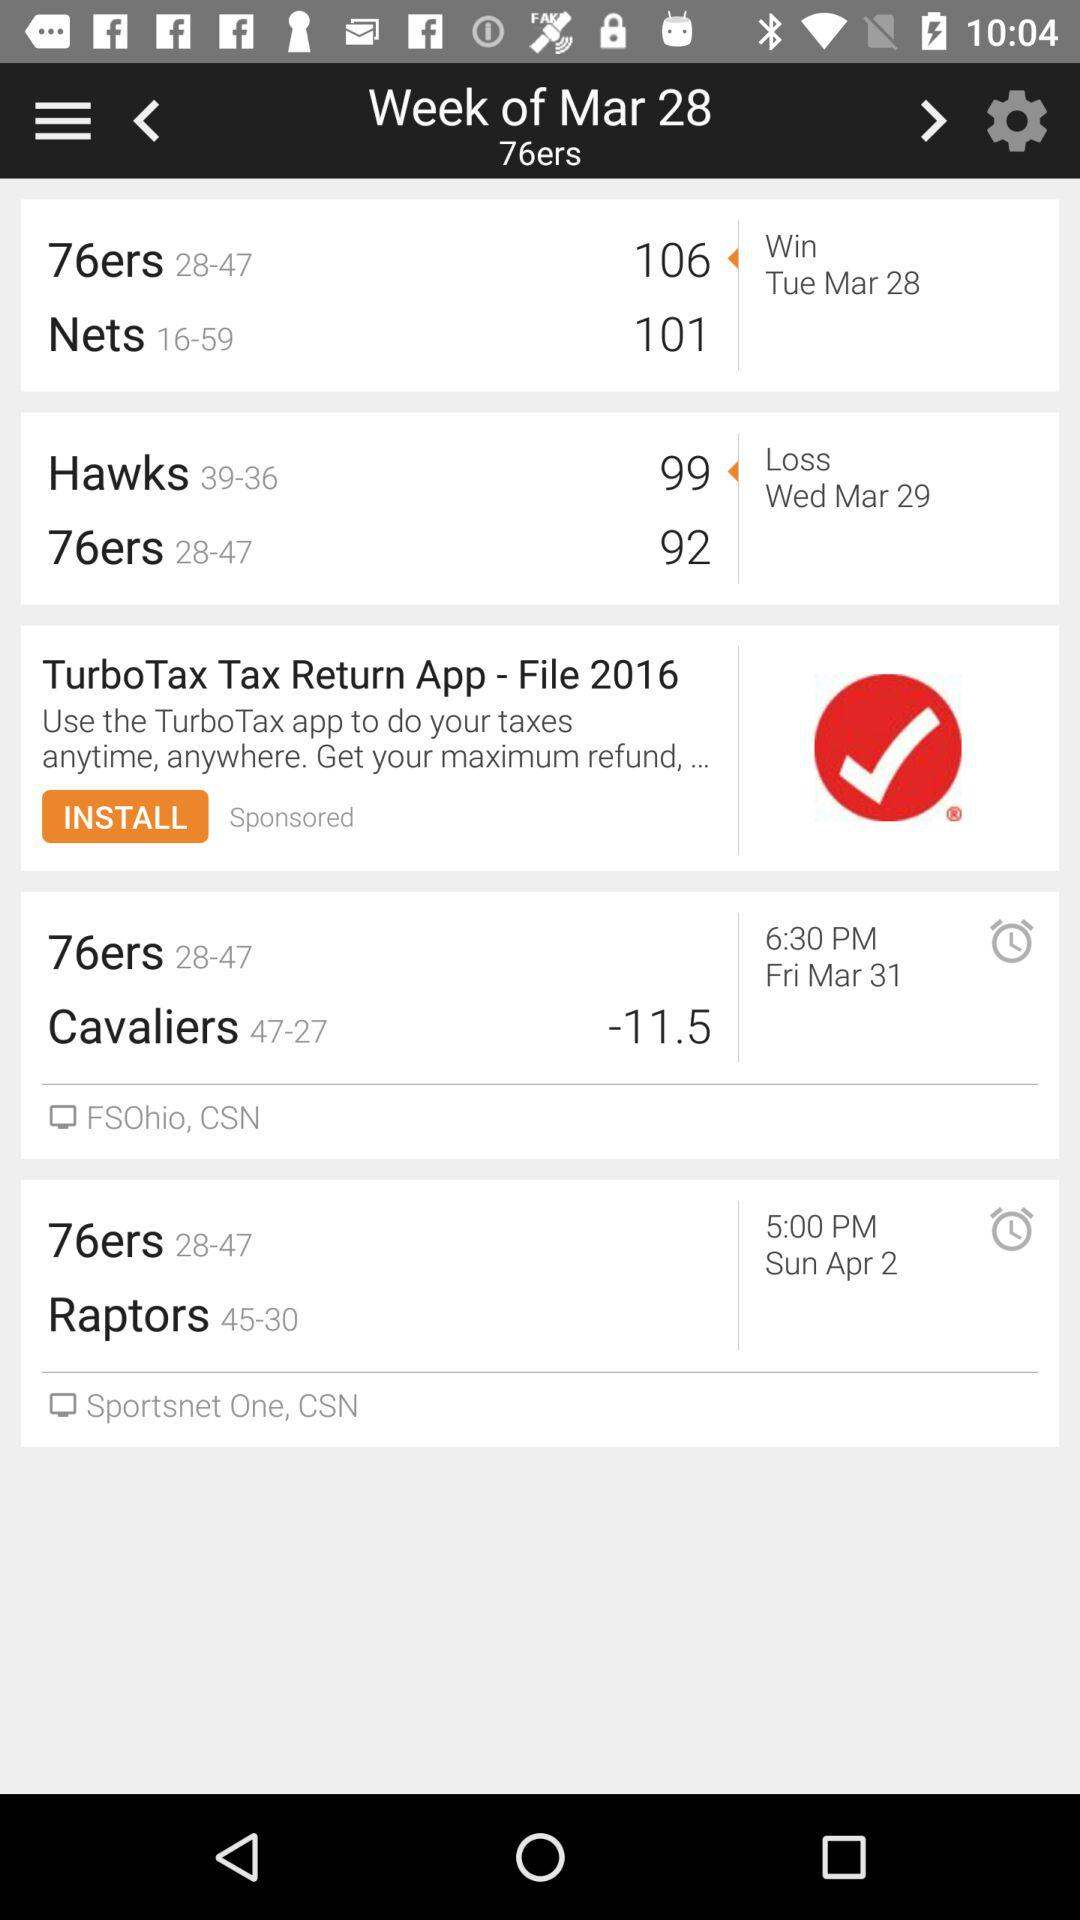What is the score of "Hawks" on March 29? The score of "Hawks" on March 29 is 99. 